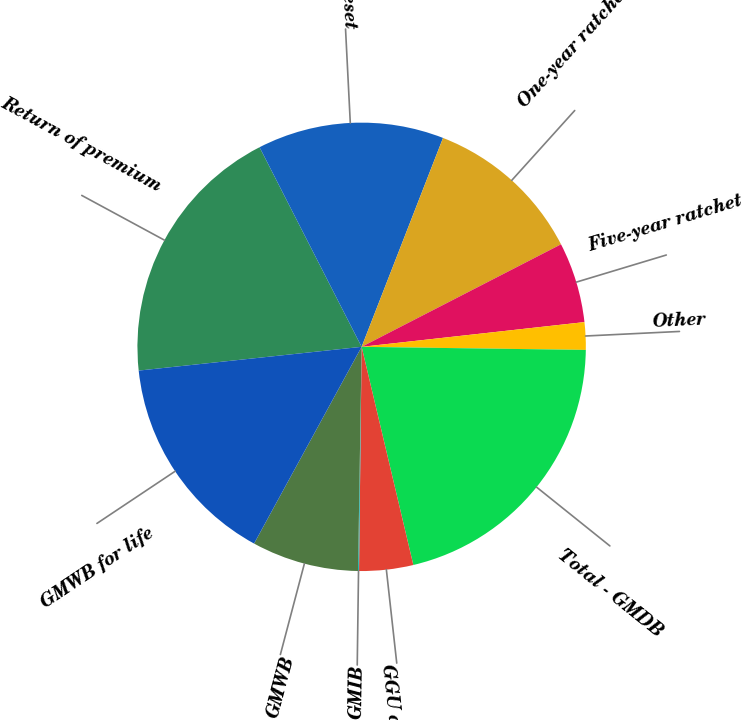Convert chart to OTSL. <chart><loc_0><loc_0><loc_500><loc_500><pie_chart><fcel>Return of premium<fcel>Five/six-year reset<fcel>One-year ratchet<fcel>Five-year ratchet<fcel>Other<fcel>Total - GMDB<fcel>GGU death benefit<fcel>GMIB<fcel>GMWB<fcel>GMWB for life<nl><fcel>19.17%<fcel>13.44%<fcel>11.53%<fcel>5.8%<fcel>1.98%<fcel>21.08%<fcel>3.89%<fcel>0.07%<fcel>7.71%<fcel>15.35%<nl></chart> 